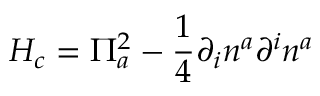<formula> <loc_0><loc_0><loc_500><loc_500>H _ { c } = \Pi _ { a } ^ { 2 } - \frac { 1 } { 4 } \partial _ { i } n ^ { a } \partial ^ { i } n ^ { a }</formula> 